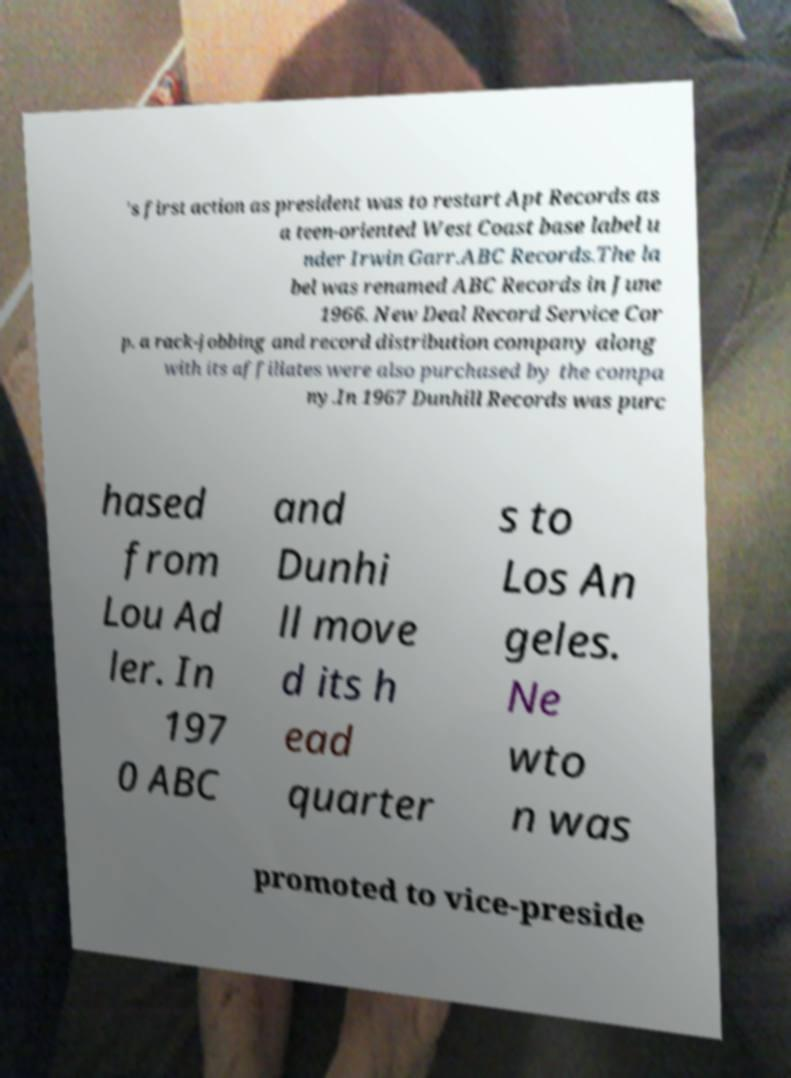I need the written content from this picture converted into text. Can you do that? 's first action as president was to restart Apt Records as a teen-oriented West Coast base label u nder Irwin Garr.ABC Records.The la bel was renamed ABC Records in June 1966. New Deal Record Service Cor p. a rack-jobbing and record distribution company along with its affiliates were also purchased by the compa ny.In 1967 Dunhill Records was purc hased from Lou Ad ler. In 197 0 ABC and Dunhi ll move d its h ead quarter s to Los An geles. Ne wto n was promoted to vice-preside 